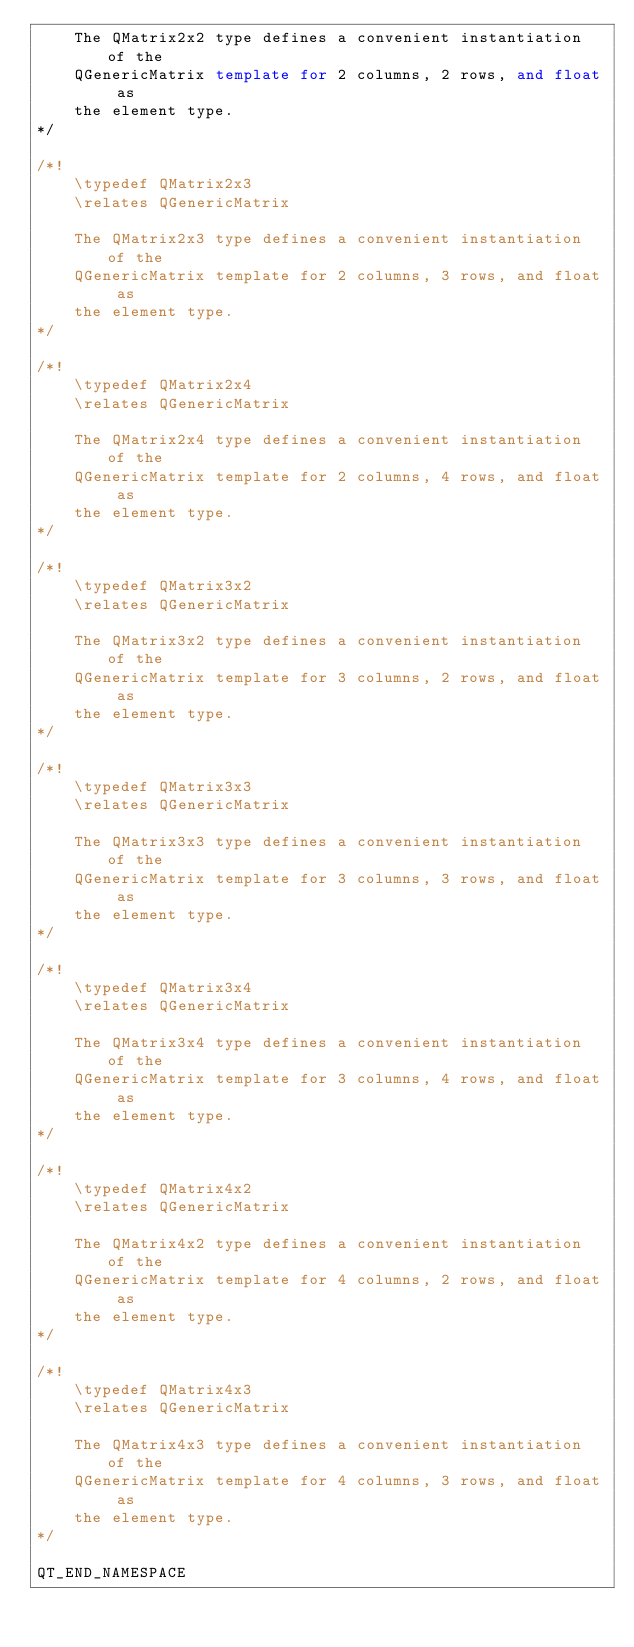<code> <loc_0><loc_0><loc_500><loc_500><_C++_>    The QMatrix2x2 type defines a convenient instantiation of the
    QGenericMatrix template for 2 columns, 2 rows, and float as
    the element type.
*/

/*!
    \typedef QMatrix2x3
    \relates QGenericMatrix

    The QMatrix2x3 type defines a convenient instantiation of the
    QGenericMatrix template for 2 columns, 3 rows, and float as
    the element type.
*/

/*!
    \typedef QMatrix2x4
    \relates QGenericMatrix

    The QMatrix2x4 type defines a convenient instantiation of the
    QGenericMatrix template for 2 columns, 4 rows, and float as
    the element type.
*/

/*!
    \typedef QMatrix3x2
    \relates QGenericMatrix

    The QMatrix3x2 type defines a convenient instantiation of the
    QGenericMatrix template for 3 columns, 2 rows, and float as
    the element type.
*/

/*!
    \typedef QMatrix3x3
    \relates QGenericMatrix

    The QMatrix3x3 type defines a convenient instantiation of the
    QGenericMatrix template for 3 columns, 3 rows, and float as
    the element type.
*/

/*!
    \typedef QMatrix3x4
    \relates QGenericMatrix

    The QMatrix3x4 type defines a convenient instantiation of the
    QGenericMatrix template for 3 columns, 4 rows, and float as
    the element type.
*/

/*!
    \typedef QMatrix4x2
    \relates QGenericMatrix

    The QMatrix4x2 type defines a convenient instantiation of the
    QGenericMatrix template for 4 columns, 2 rows, and float as
    the element type.
*/

/*!
    \typedef QMatrix4x3
    \relates QGenericMatrix

    The QMatrix4x3 type defines a convenient instantiation of the
    QGenericMatrix template for 4 columns, 3 rows, and float as
    the element type.
*/

QT_END_NAMESPACE
</code> 